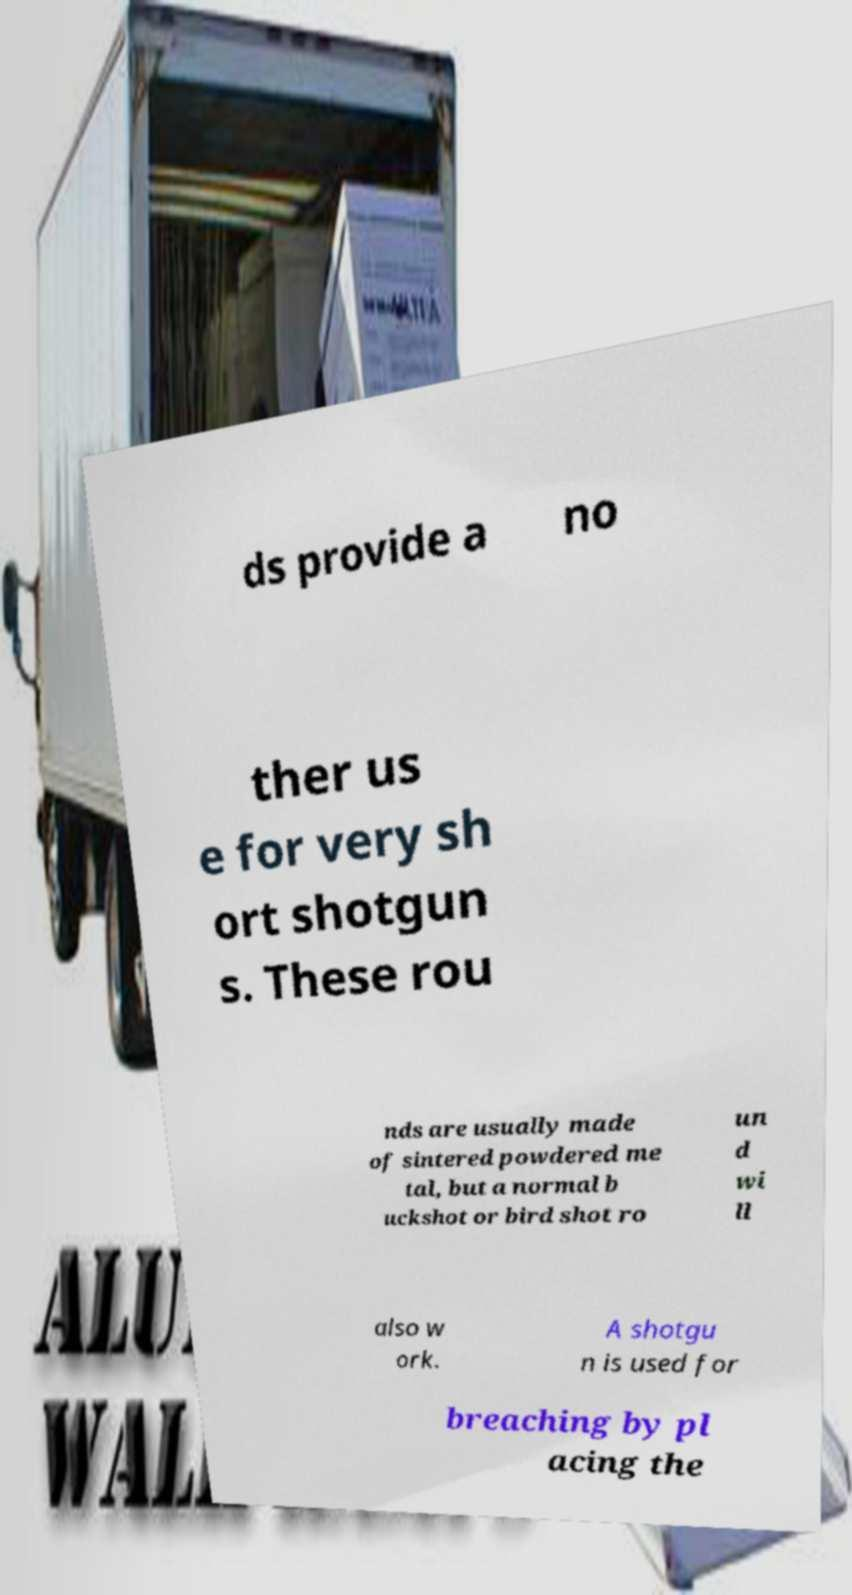Could you assist in decoding the text presented in this image and type it out clearly? ds provide a no ther us e for very sh ort shotgun s. These rou nds are usually made of sintered powdered me tal, but a normal b uckshot or bird shot ro un d wi ll also w ork. A shotgu n is used for breaching by pl acing the 